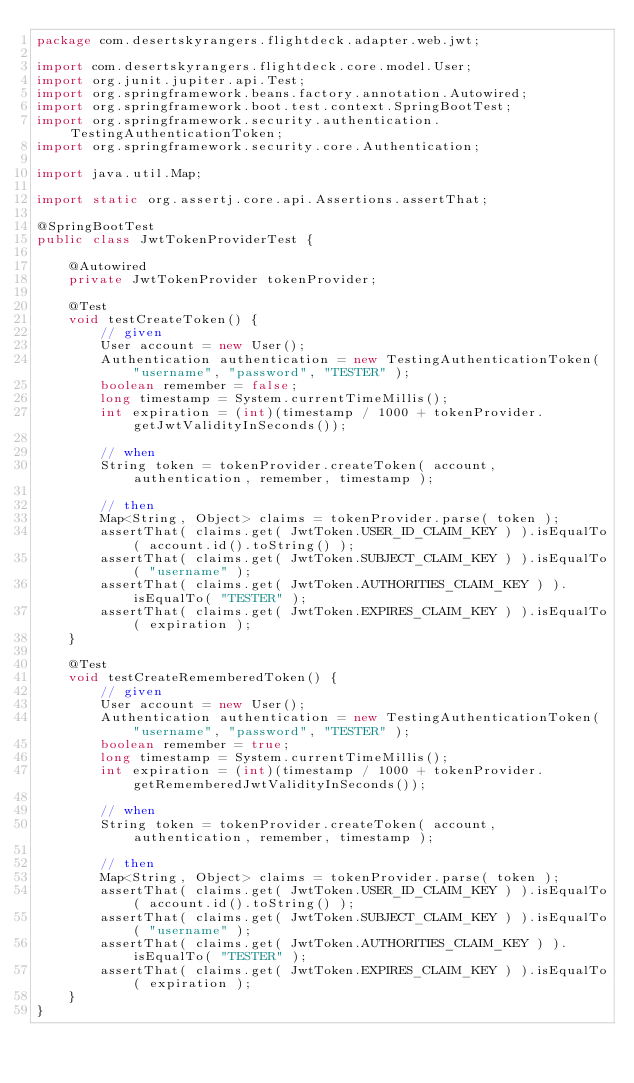Convert code to text. <code><loc_0><loc_0><loc_500><loc_500><_Java_>package com.desertskyrangers.flightdeck.adapter.web.jwt;

import com.desertskyrangers.flightdeck.core.model.User;
import org.junit.jupiter.api.Test;
import org.springframework.beans.factory.annotation.Autowired;
import org.springframework.boot.test.context.SpringBootTest;
import org.springframework.security.authentication.TestingAuthenticationToken;
import org.springframework.security.core.Authentication;

import java.util.Map;

import static org.assertj.core.api.Assertions.assertThat;

@SpringBootTest
public class JwtTokenProviderTest {

	@Autowired
	private JwtTokenProvider tokenProvider;

	@Test
	void testCreateToken() {
		// given
		User account = new User();
		Authentication authentication = new TestingAuthenticationToken( "username", "password", "TESTER" );
		boolean remember = false;
		long timestamp = System.currentTimeMillis();
		int expiration = (int)(timestamp / 1000 + tokenProvider.getJwtValidityInSeconds());

		// when
		String token = tokenProvider.createToken( account, authentication, remember, timestamp );

		// then
		Map<String, Object> claims = tokenProvider.parse( token );
		assertThat( claims.get( JwtToken.USER_ID_CLAIM_KEY ) ).isEqualTo( account.id().toString() );
		assertThat( claims.get( JwtToken.SUBJECT_CLAIM_KEY ) ).isEqualTo( "username" );
		assertThat( claims.get( JwtToken.AUTHORITIES_CLAIM_KEY ) ).isEqualTo( "TESTER" );
		assertThat( claims.get( JwtToken.EXPIRES_CLAIM_KEY ) ).isEqualTo( expiration );
	}

	@Test
	void testCreateRememberedToken() {
		// given
		User account = new User();
		Authentication authentication = new TestingAuthenticationToken( "username", "password", "TESTER" );
		boolean remember = true;
		long timestamp = System.currentTimeMillis();
		int expiration = (int)(timestamp / 1000 + tokenProvider.getRememberedJwtValidityInSeconds());

		// when
		String token = tokenProvider.createToken( account, authentication, remember, timestamp );

		// then
		Map<String, Object> claims = tokenProvider.parse( token );
		assertThat( claims.get( JwtToken.USER_ID_CLAIM_KEY ) ).isEqualTo( account.id().toString() );
		assertThat( claims.get( JwtToken.SUBJECT_CLAIM_KEY ) ).isEqualTo( "username" );
		assertThat( claims.get( JwtToken.AUTHORITIES_CLAIM_KEY ) ).isEqualTo( "TESTER" );
		assertThat( claims.get( JwtToken.EXPIRES_CLAIM_KEY ) ).isEqualTo( expiration );
	}
}
</code> 